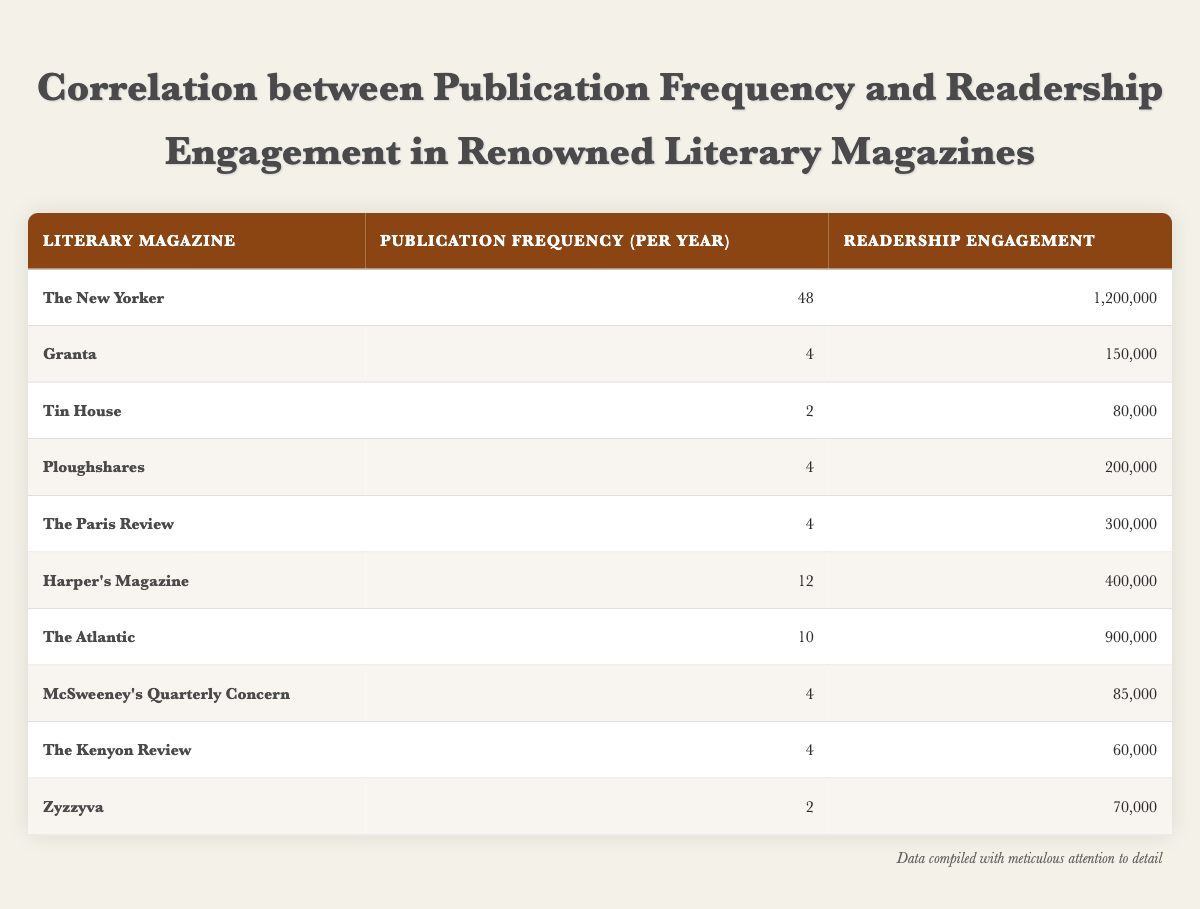What is the publication frequency of The New Yorker? The publication frequency for The New Yorker is listed in the table under the corresponding heading, which shows a frequency of 48 publications per year.
Answer: 48 What is the readership engagement of Granta? The readership engagement for Granta can be found directly in the table next to its name, stating that it has an engagement of 150,000.
Answer: 150,000 How many literary magazines have a publication frequency of 4 or more? Reviewing the table, we count the magazines with a frequency of 4 or more: The New Yorker (48), Harper's Magazine (12), The Atlantic (10), and 4 magazines with a frequency of 4. That totals 7 magazines.
Answer: 7 What is the average readership engagement of magazines with a publication frequency of 4? The magazines with a frequency of 4 are Granta (150,000), Ploughshares (200,000), The Paris Review (300,000), McSweeney's Quarterly Concern (85,000), and The Kenyon Review (60,000). Adding these values gives 150,000 + 200,000 + 300,000 + 85,000 + 60,000 = 795,000. There are 5 magazines, so the average is 795,000 / 5 = 159,000.
Answer: 159,000 Is the readership engagement for Tin House greater than that for Zyzzyva? Based on the table, Tin House has a readership engagement of 80,000 while Zyzzyva has an engagement of 70,000. Since 80,000 is greater than 70,000, the answer is yes.
Answer: Yes Which magazine has the highest readership engagement, and how does it compare to the average engagement of all magazines? From the table, The New Yorker has the highest engagement at 1,200,000. To find the average engagement, we sum all engagements (1,200,000 + 150,000 + 80,000 + 200,000 + 300,000 + 400,000 + 900,000 + 85,000 + 60,000 + 70,000 = 3,545,000) and divide by the number of magazines (10), resulting in an average of 354,500. Comparing, 1,200,000 is much higher than the average of 354,500.
Answer: The New Yorker is the highest, significantly above average How many magazines have a readership engagement below 100,000? Scanning the table, we find that Tin House (80,000), McSweeney's Quarterly Concern (85,000), The Kenyon Review (60,000), and Zyzzyva (70,000) have engagement below 100,000. This counts to 4 magazines.
Answer: 4 What is the difference between the highest and lowest publication frequency? The highest publication frequency is 48 (The New Yorker) and the lowest is 2 (Tin House and Zyzzyva). The difference is calculated as 48 - 2 = 46.
Answer: 46 